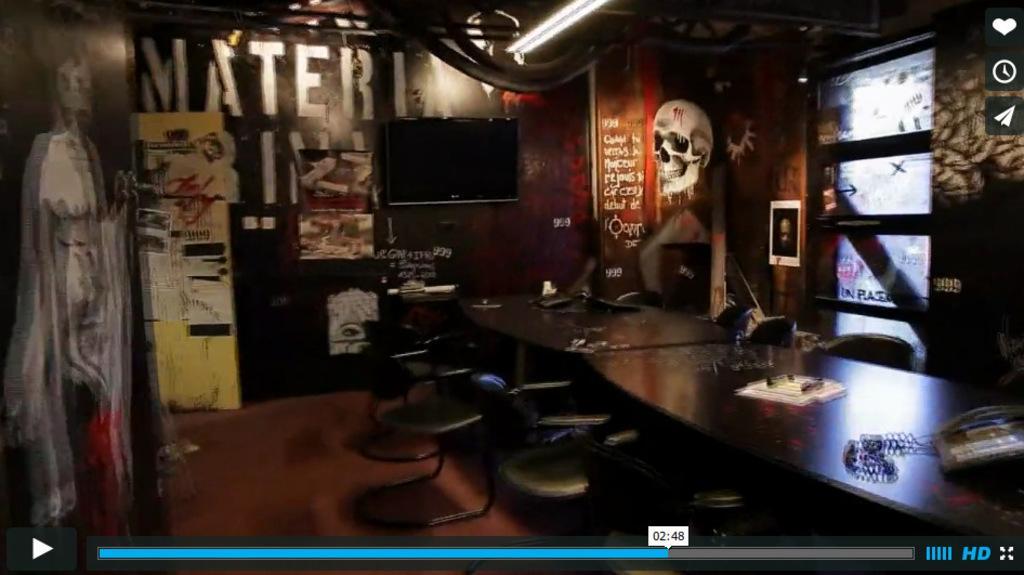Describe this image in one or two sentences. This image is a picture of a video, in this image there are chairs, tables on that tables there are telephone, papers and few items and in the background there are walls for that wall there are monitor and there is some text and painting, at the top there is light. 